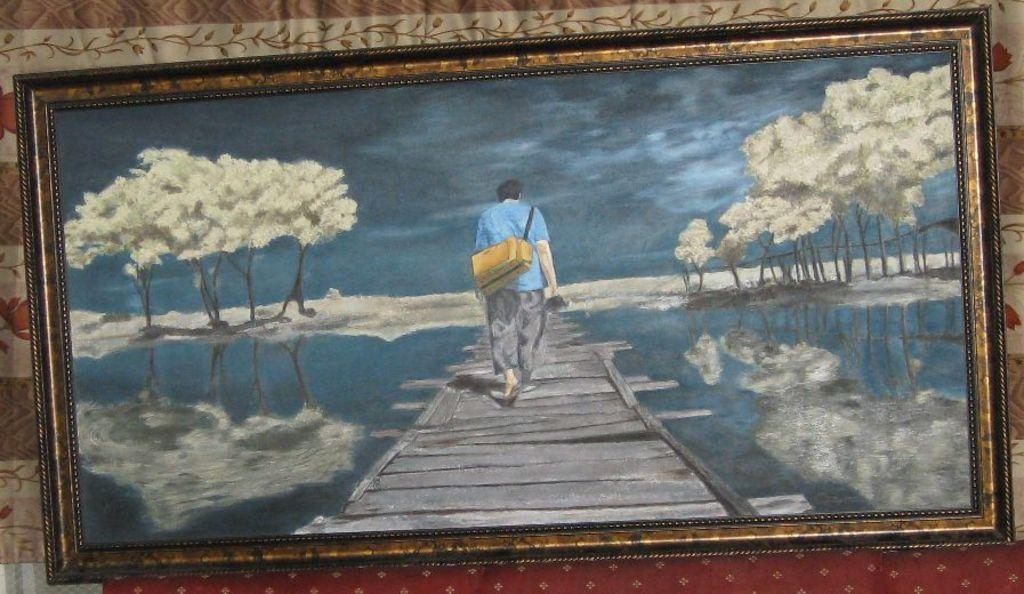What is the main object in the image? There is a frame in the image. What is the frame placed on? The frame is on a cloth. What type of substance is being exchanged between the frame and the cloth in the image? There is no substance exchange between the frame and the cloth in the image; the frame is simply placed on the cloth. What type of iron is visible in the image? There is no iron present in the image. 